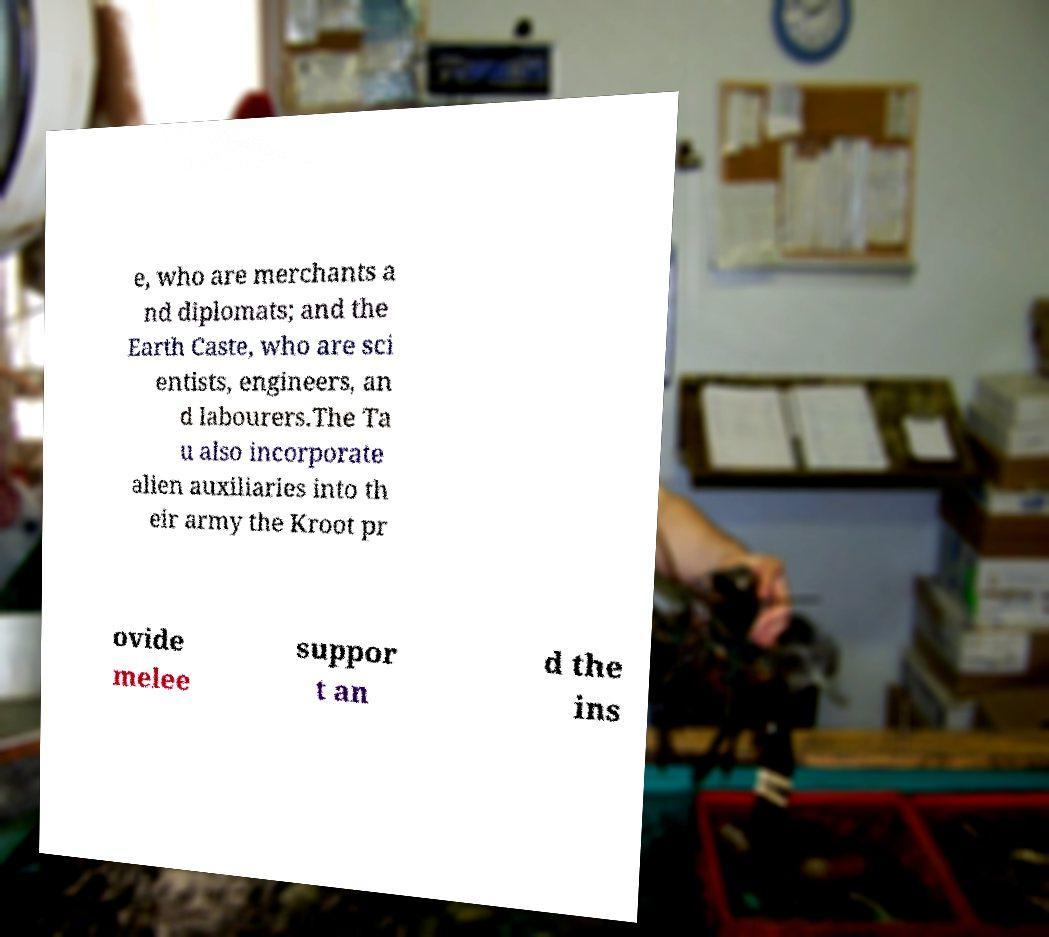Please identify and transcribe the text found in this image. e, who are merchants a nd diplomats; and the Earth Caste, who are sci entists, engineers, an d labourers.The Ta u also incorporate alien auxiliaries into th eir army the Kroot pr ovide melee suppor t an d the ins 